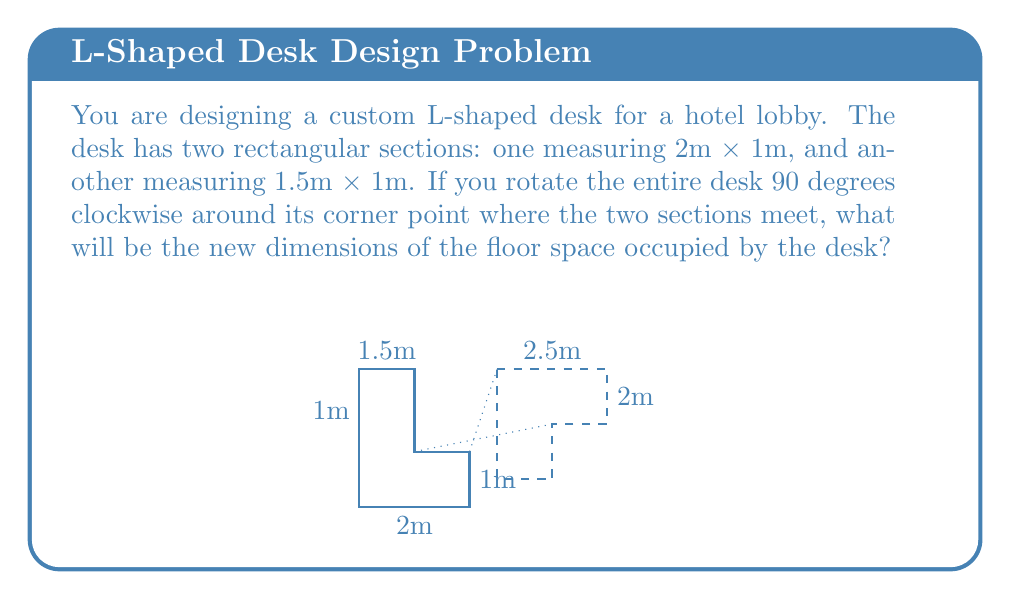Provide a solution to this math problem. To solve this problem, we need to visualize the rotation and calculate the new dimensions. Let's break it down step-by-step:

1) Before rotation:
   - Section 1: 2m x 1m
   - Section 2: 1.5m x 1m
   
2) After 90-degree clockwise rotation:
   - The 2m length of Section 1 becomes the new width
   - The combined lengths of both sections (1m + 1.5m = 2.5m) become the new length
   
3) Calculating new dimensions:
   - New width: $w = 2\text{m}$
   - New length: $l = 1\text{m} + 1.5\text{m} = 2.5\text{m}$

4) The new floor space occupied by the desk will be a rectangle measuring 2.5m x 2m.

This rotation effectively transforms the L-shape into a rectangle, maximizing the use of space in a different configuration.
Answer: 2.5m x 2m 